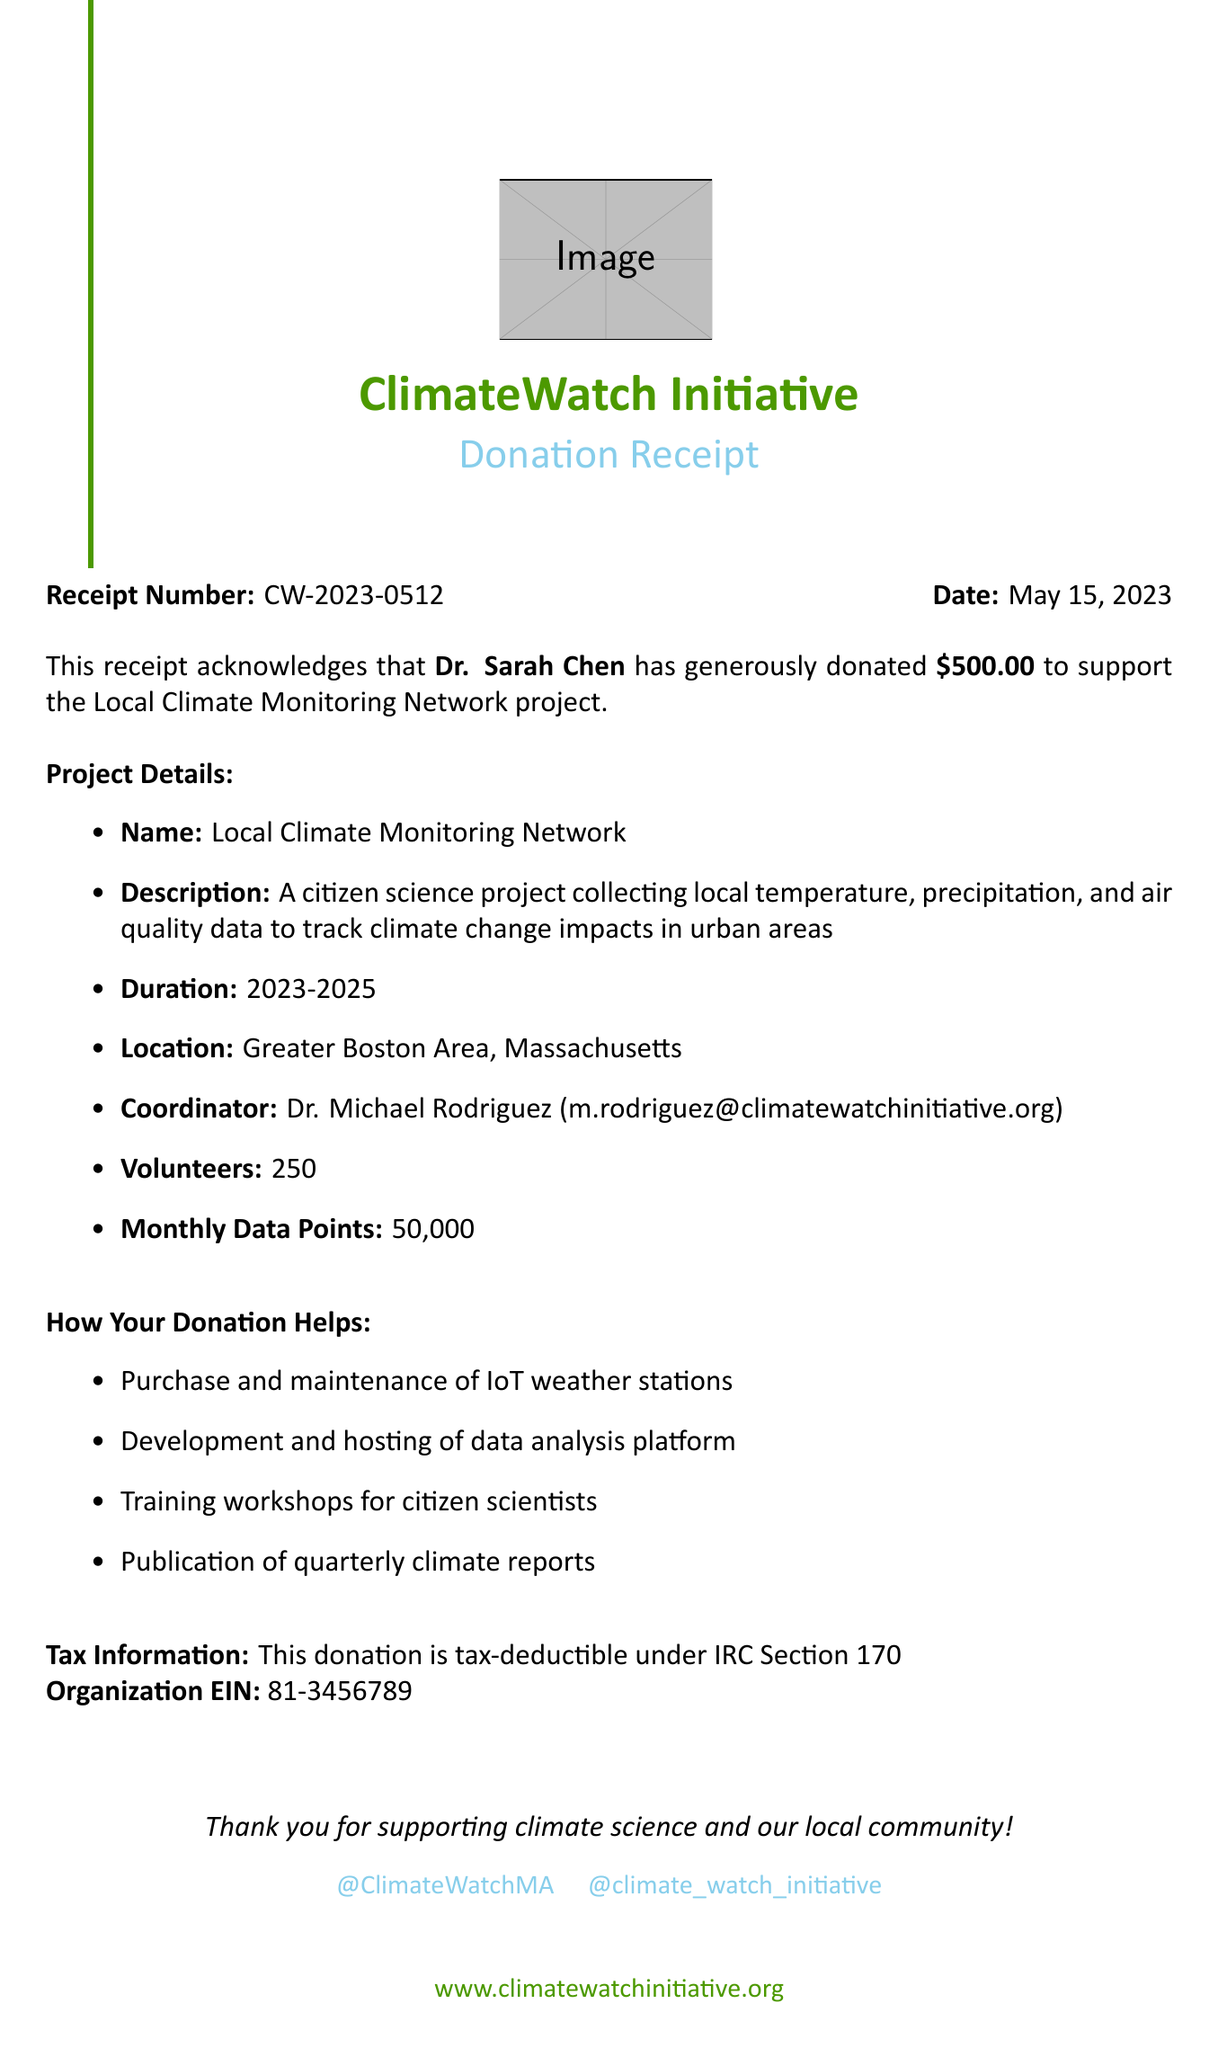What is the name of the organization? The organization name is provided at the beginning of the receipt.
Answer: ClimateWatch Initiative Who is the donor? The donor's name is mentioned in the receipt.
Answer: Dr. Sarah Chen What is the donation amount? The donation amount is specified clearly in the document.
Answer: $500.00 When was the donation made? The donation date is explicitly stated on the receipt.
Answer: May 15, 2023 What is the project duration? The duration of the project is outlined in the project details section.
Answer: 2023-2025 How many volunteers are involved in the project? The number of volunteers is mentioned in the project details.
Answer: 250 What method is used for data collection? The document lists methods for data collection in the project description.
Answer: IoT weather stations, Mobile app for manual observations, Satellite imagery analysis What is the tax deduction information? The document includes a section about tax-deductible donations.
Answer: This donation is tax-deductible under IRC Section 170 Who is the project coordinator? The coordinator's name is provided in the project details section.
Answer: Dr. Michael Rodriguez 